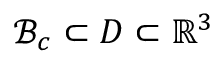<formula> <loc_0><loc_0><loc_500><loc_500>\mathcal { B } _ { c } \subset D \subset { \mathbb { R } } ^ { 3 }</formula> 